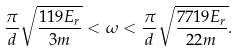<formula> <loc_0><loc_0><loc_500><loc_500>\frac { \pi } { d } \sqrt { \frac { 1 1 9 E _ { r } } { 3 m } } < \omega < \frac { \pi } { d } \sqrt { \frac { 7 7 1 9 E _ { r } } { 2 2 m } } .</formula> 